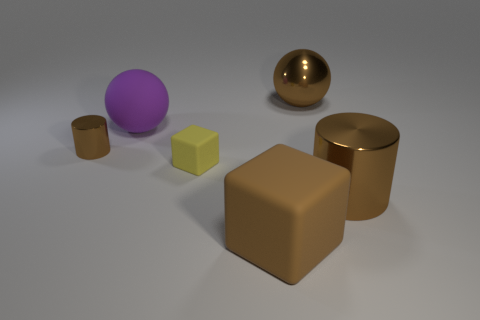Can you describe the setting and lighting of this composition? The image portrays a simple, minimalist setting with a selection of objects placed casually. These objects sit on a flat surface, illuminated from above, which casts soft shadows beneath each item, suggesting a soft yet direct light source, typical of studio lighting. This controlled environment is often used in object rendering to showcase shapes and colors without external interference. 